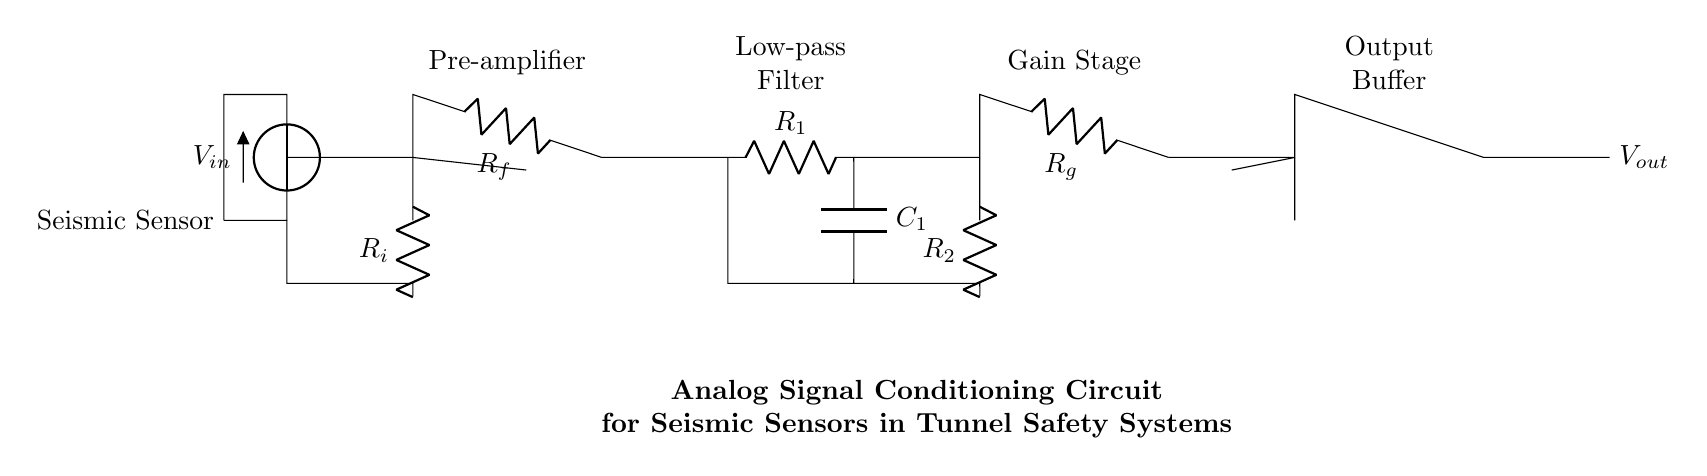What is the function of the pre-amplifier? The pre-amplifier boosts the initial weak signal from the seismic sensor to a usable level, preparing it for further processing.
Answer: Boosts signal What type of filter is used in this circuit? A low-pass filter is used to allow low-frequency signals through while attenuating high-frequency noise.
Answer: Low-pass filter What is the role of the output buffer? The output buffer provides isolation from the load, ensuring that the output voltage is stable and not affected by the load impedance.
Answer: Isolation How many operational amplifiers are present in the circuit? There are three operational amplifiers used in the pre-amplifier, gain stage, and output buffer sections.
Answer: Three What does the resistor labeled R_f represent? R_f is the feedback resistor in the pre-amplifier stage, setting the gain of the amplifier.
Answer: Feedback resistor What is the purpose of the capacitor C_1 in the low-pass filter? C_1 works with the resistor R_1 to define the cut-off frequency, helping to filter out unwanted high-frequency noise.
Answer: Define cut-off frequency What is the significance of the gain stage in the circuit? The gain stage further amplifies the conditioned signal from the low-pass filter, providing additional gain before output.
Answer: Further amplifies signal 